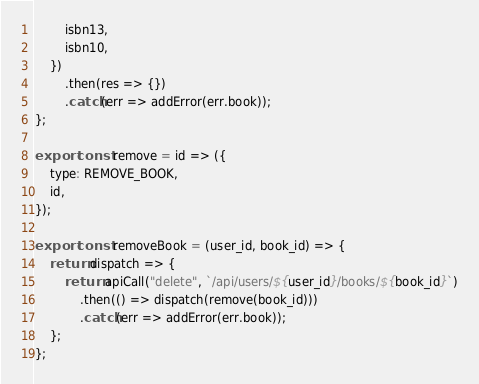Convert code to text. <code><loc_0><loc_0><loc_500><loc_500><_JavaScript_>        isbn13,
        isbn10,
    })
        .then(res => {})
        .catch(err => addError(err.book));
};

export const remove = id => ({
    type: REMOVE_BOOK,
    id,
});

export const removeBook = (user_id, book_id) => {
    return dispatch => {
        return apiCall("delete", `/api/users/${user_id}/books/${book_id}`)
            .then(() => dispatch(remove(book_id)))
            .catch(err => addError(err.book));
    };
};
</code> 